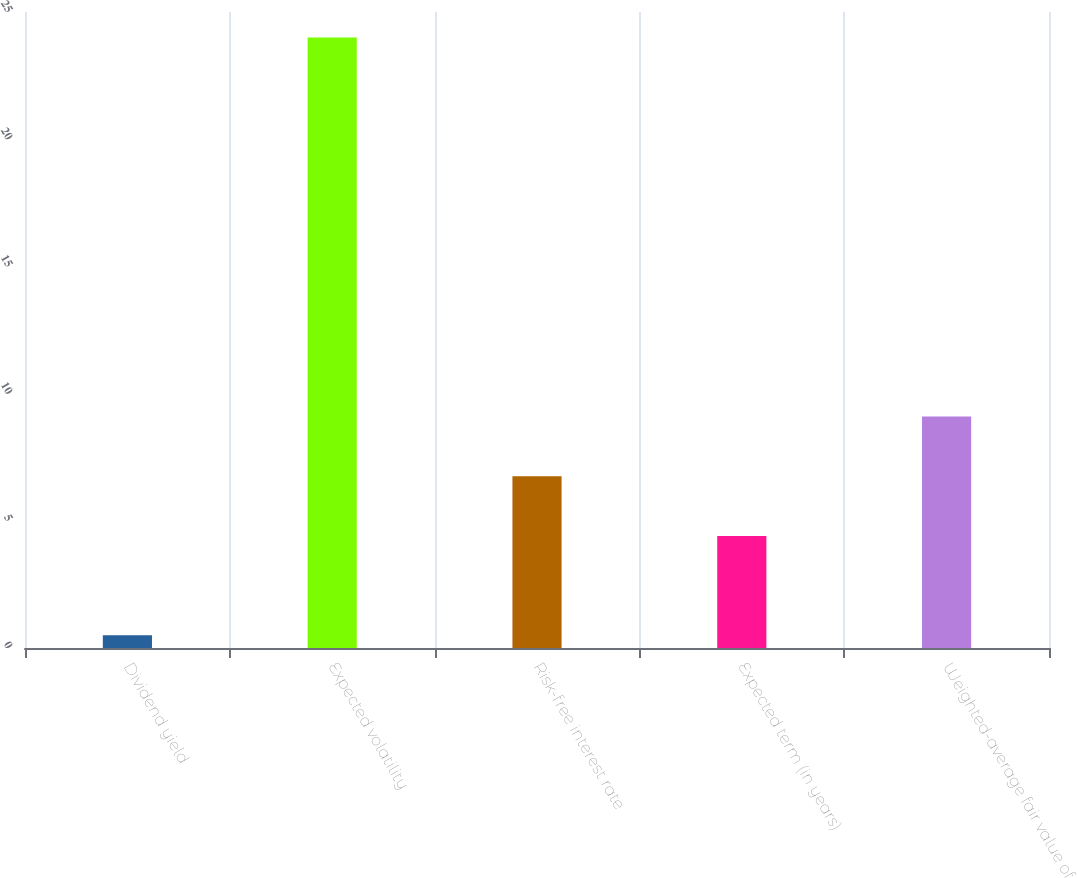Convert chart to OTSL. <chart><loc_0><loc_0><loc_500><loc_500><bar_chart><fcel>Dividend yield<fcel>Expected volatility<fcel>Risk-free interest rate<fcel>Expected term (in years)<fcel>Weighted-average fair value of<nl><fcel>0.5<fcel>24<fcel>6.75<fcel>4.4<fcel>9.1<nl></chart> 